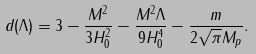<formula> <loc_0><loc_0><loc_500><loc_500>d ( \Lambda ) = 3 - \frac { M ^ { 2 } } { 3 H _ { 0 } ^ { 2 } } - \frac { M ^ { 2 } \Lambda } { 9 H _ { 0 } ^ { 4 } } - \frac { m } { 2 \sqrt { \pi } M _ { p } } .</formula> 